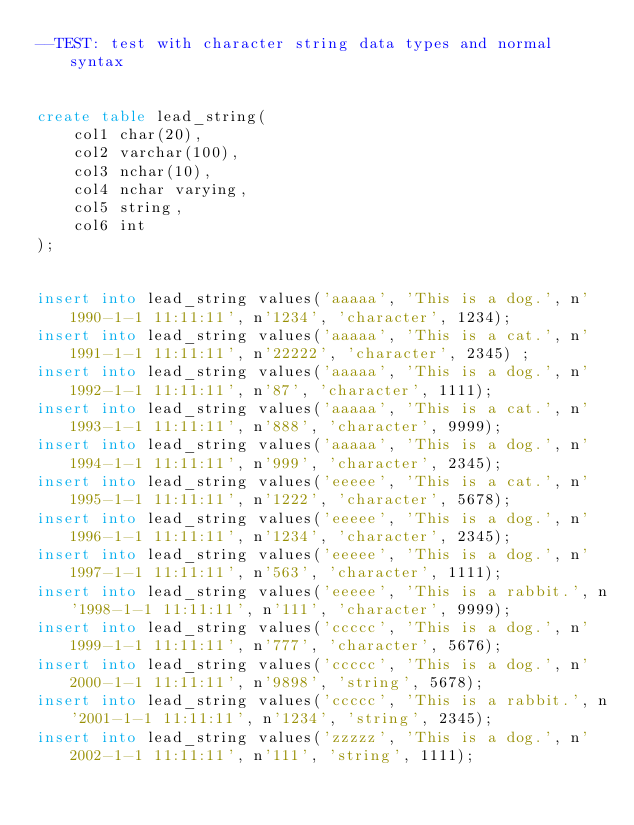Convert code to text. <code><loc_0><loc_0><loc_500><loc_500><_SQL_>--TEST: test with character string data types and normal syntax 


create table lead_string(
	col1 char(20),
	col2 varchar(100), 
	col3 nchar(10),
	col4 nchar varying,
	col5 string,
	col6 int
);


insert into lead_string values('aaaaa', 'This is a dog.', n'1990-1-1 11:11:11', n'1234', 'character', 1234);
insert into lead_string values('aaaaa', 'This is a cat.', n'1991-1-1 11:11:11', n'22222', 'character', 2345) ;
insert into lead_string values('aaaaa', 'This is a dog.', n'1992-1-1 11:11:11', n'87', 'character', 1111);
insert into lead_string values('aaaaa', 'This is a cat.', n'1993-1-1 11:11:11', n'888', 'character', 9999);
insert into lead_string values('aaaaa', 'This is a dog.', n'1994-1-1 11:11:11', n'999', 'character', 2345);
insert into lead_string values('eeeee', 'This is a cat.', n'1995-1-1 11:11:11', n'1222', 'character', 5678);
insert into lead_string values('eeeee', 'This is a dog.', n'1996-1-1 11:11:11', n'1234', 'character', 2345);
insert into lead_string values('eeeee', 'This is a dog.', n'1997-1-1 11:11:11', n'563', 'character', 1111);
insert into lead_string values('eeeee', 'This is a rabbit.', n'1998-1-1 11:11:11', n'111', 'character', 9999);
insert into lead_string values('ccccc', 'This is a dog.', n'1999-1-1 11:11:11', n'777', 'character', 5676);
insert into lead_string values('ccccc', 'This is a dog.', n'2000-1-1 11:11:11', n'9898', 'string', 5678);
insert into lead_string values('ccccc', 'This is a rabbit.', n'2001-1-1 11:11:11', n'1234', 'string', 2345);
insert into lead_string values('zzzzz', 'This is a dog.', n'2002-1-1 11:11:11', n'111', 'string', 1111);</code> 